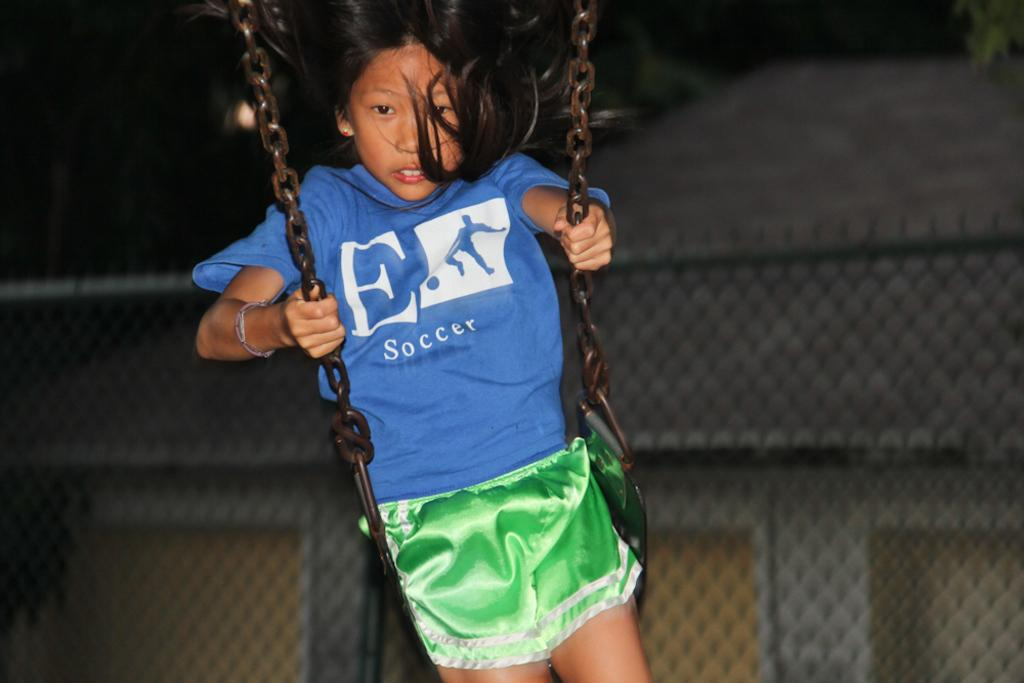<image>
Describe the image concisely. A chld on a swing wearing a tshirt that says soccer. 